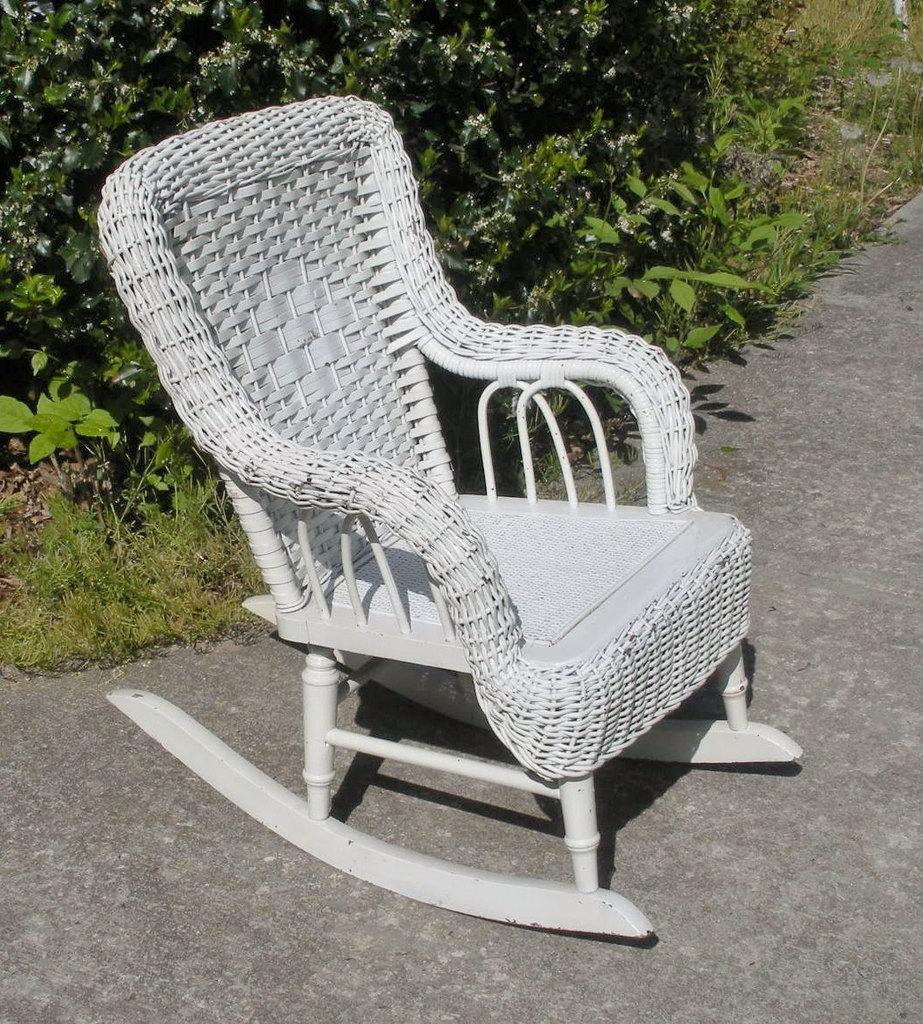Please provide a concise description of this image. In this image we can see a white color chair. There are many plants in the image. 